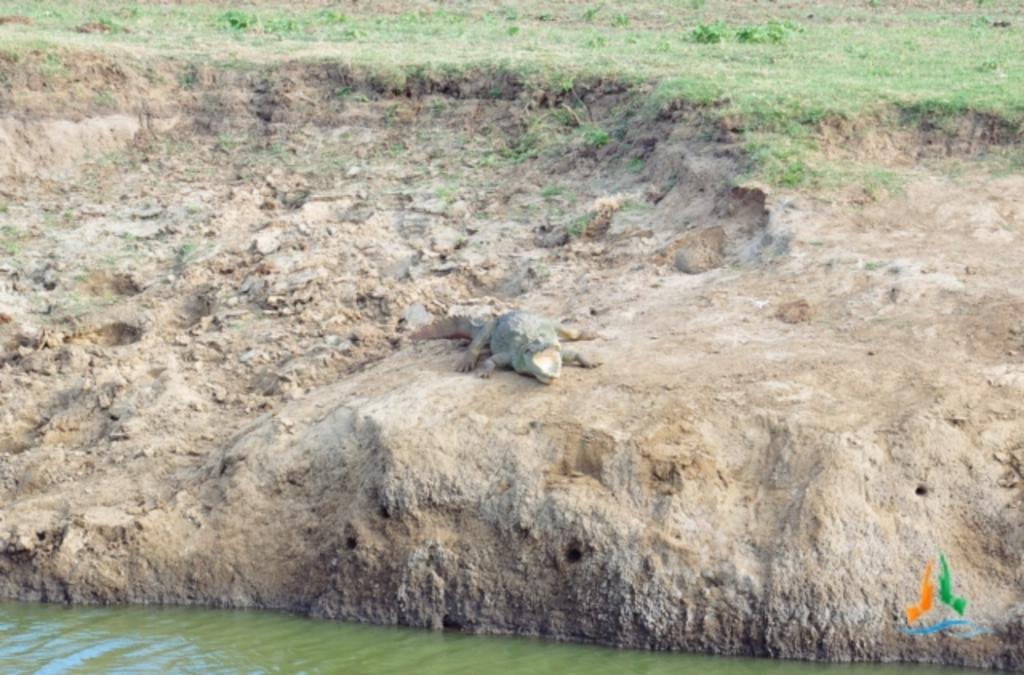What is located at the bottom of the picture? There is water at the bottom of the picture, possibly in a pond. What can be seen in the middle of the picture? There is a crocodile in the middle of the picture. What type of vegetation is visible in the background of the picture? There is grass visible in the background of the picture. What type of vessel is the crocodile using to navigate the water in the image? There is no vessel present in the image; the crocodile is in the water without any additional means of navigation. Can you tell me how many scissors are visible in the image? There are no scissors present in the image. 